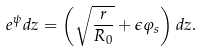Convert formula to latex. <formula><loc_0><loc_0><loc_500><loc_500>e ^ { \psi } d z = \left ( \sqrt { \frac { r } { R _ { 0 } } } + \epsilon \varphi _ { s } \right ) d z .</formula> 